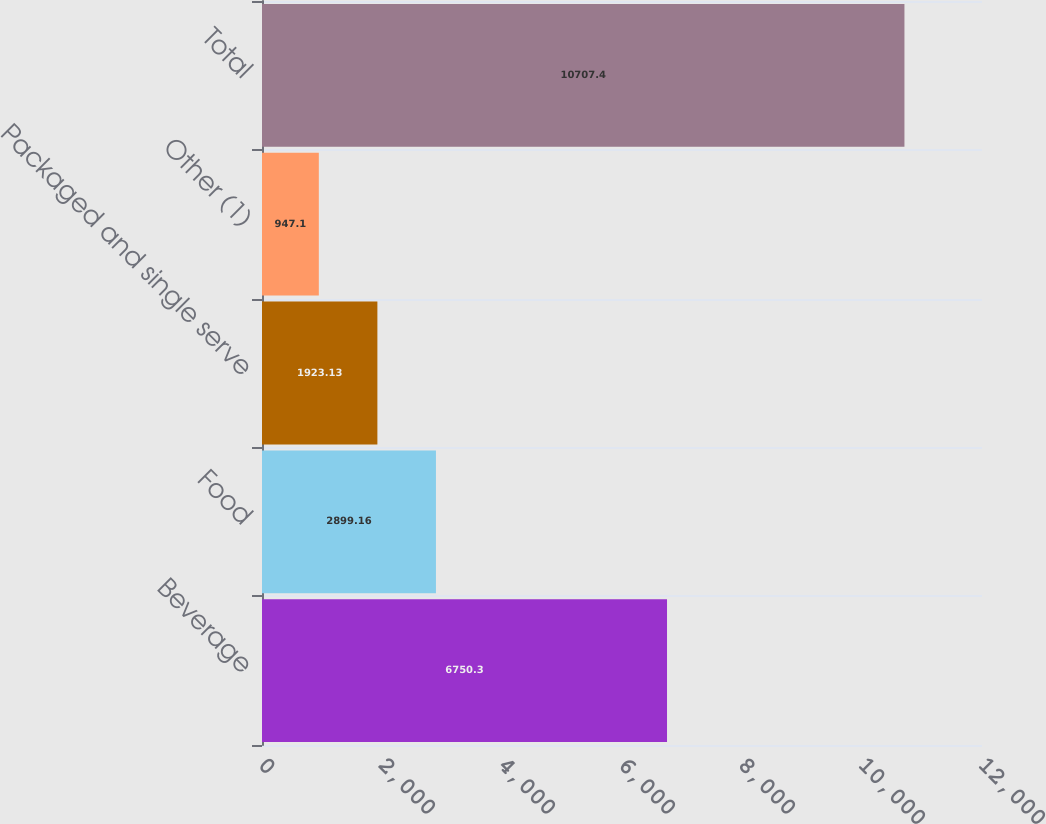Convert chart to OTSL. <chart><loc_0><loc_0><loc_500><loc_500><bar_chart><fcel>Beverage<fcel>Food<fcel>Packaged and single serve<fcel>Other (1)<fcel>Total<nl><fcel>6750.3<fcel>2899.16<fcel>1923.13<fcel>947.1<fcel>10707.4<nl></chart> 